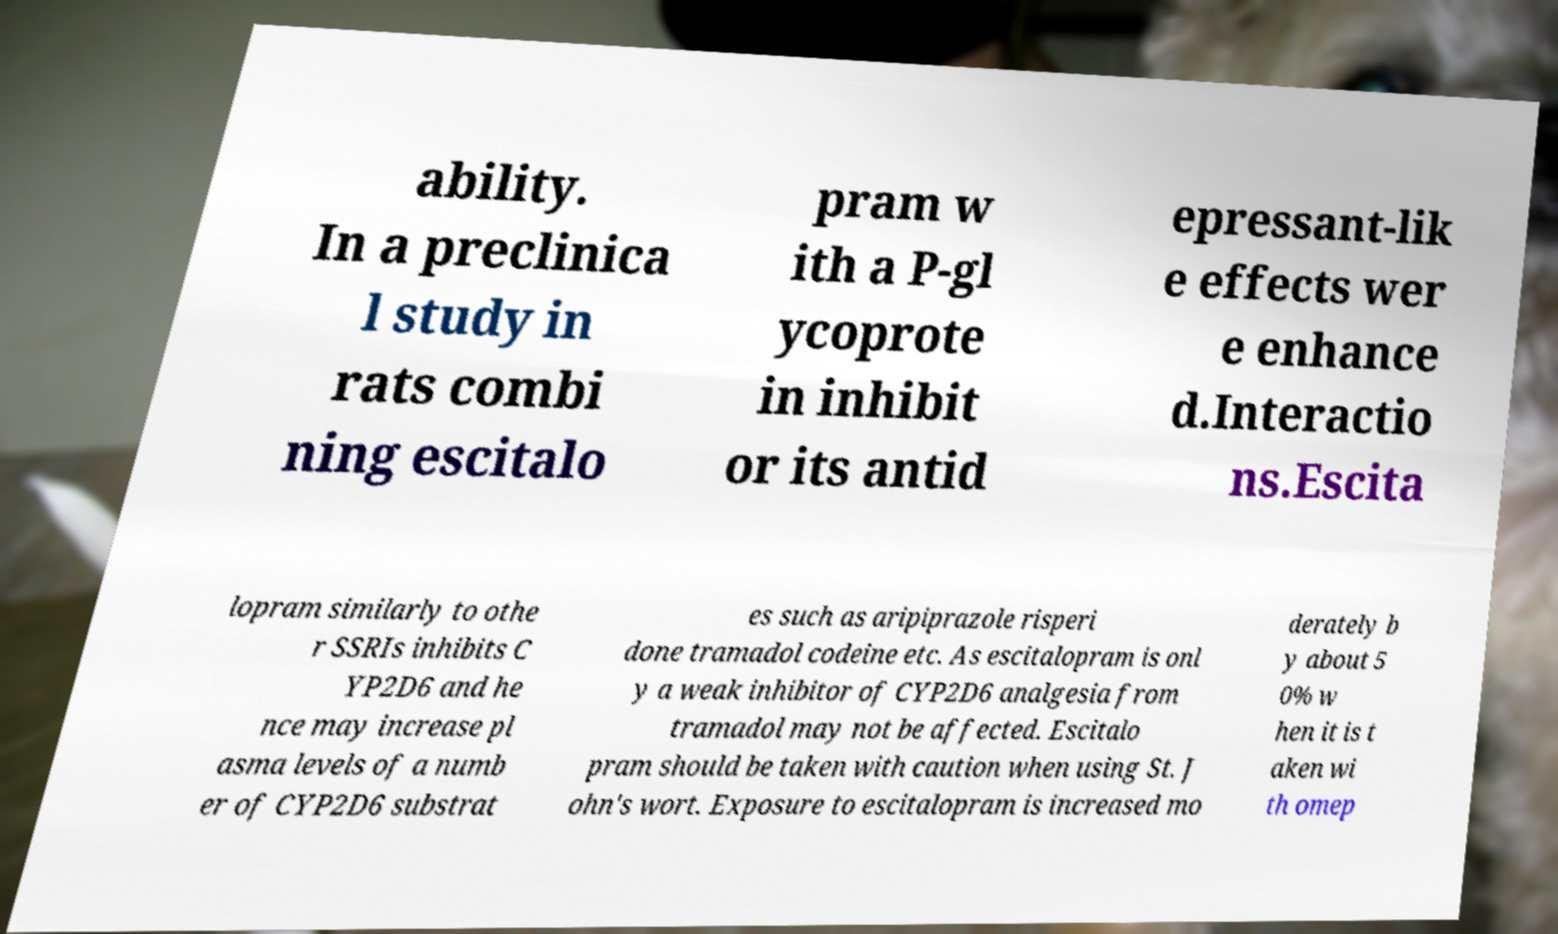Can you read and provide the text displayed in the image?This photo seems to have some interesting text. Can you extract and type it out for me? ability. In a preclinica l study in rats combi ning escitalo pram w ith a P-gl ycoprote in inhibit or its antid epressant-lik e effects wer e enhance d.Interactio ns.Escita lopram similarly to othe r SSRIs inhibits C YP2D6 and he nce may increase pl asma levels of a numb er of CYP2D6 substrat es such as aripiprazole risperi done tramadol codeine etc. As escitalopram is onl y a weak inhibitor of CYP2D6 analgesia from tramadol may not be affected. Escitalo pram should be taken with caution when using St. J ohn's wort. Exposure to escitalopram is increased mo derately b y about 5 0% w hen it is t aken wi th omep 